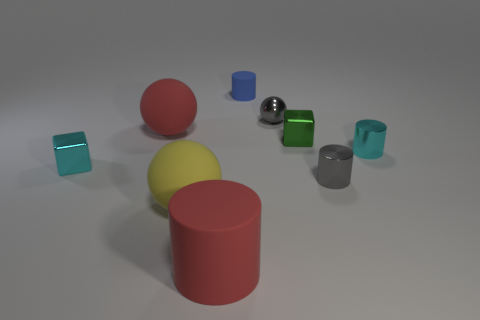There is a big rubber object that is the same color as the big matte cylinder; what is its shape?
Provide a succinct answer. Sphere. There is a gray thing behind the tiny block to the left of the big rubber cylinder; what is it made of?
Offer a terse response. Metal. There is a metal block that is to the left of the big rubber sphere that is in front of the big red matte thing that is behind the tiny green block; how big is it?
Your answer should be compact. Small. Is the green thing the same size as the cyan shiny cube?
Your answer should be very brief. Yes. Is the shape of the tiny metal thing that is on the left side of the tiny rubber cylinder the same as the cyan thing right of the blue cylinder?
Provide a short and direct response. No. There is a small blue matte object to the right of the large red sphere; is there a large rubber ball behind it?
Your response must be concise. No. Is there a large gray cube?
Provide a succinct answer. No. How many red objects have the same size as the cyan block?
Provide a short and direct response. 0. What number of small things are in front of the small cyan shiny block and left of the tiny blue rubber cylinder?
Give a very brief answer. 0. Do the cyan metallic object to the right of the gray shiny sphere and the large yellow ball have the same size?
Your answer should be very brief. No. 